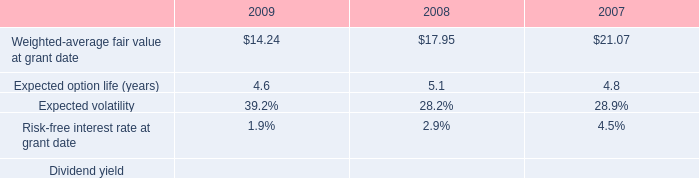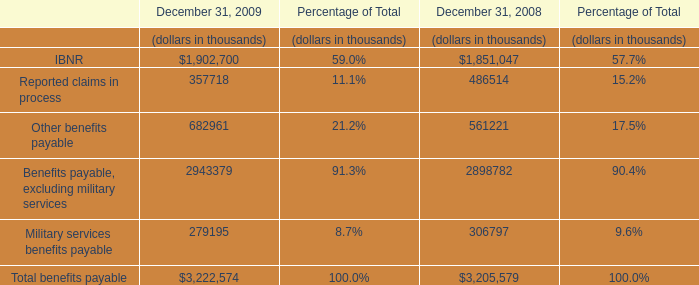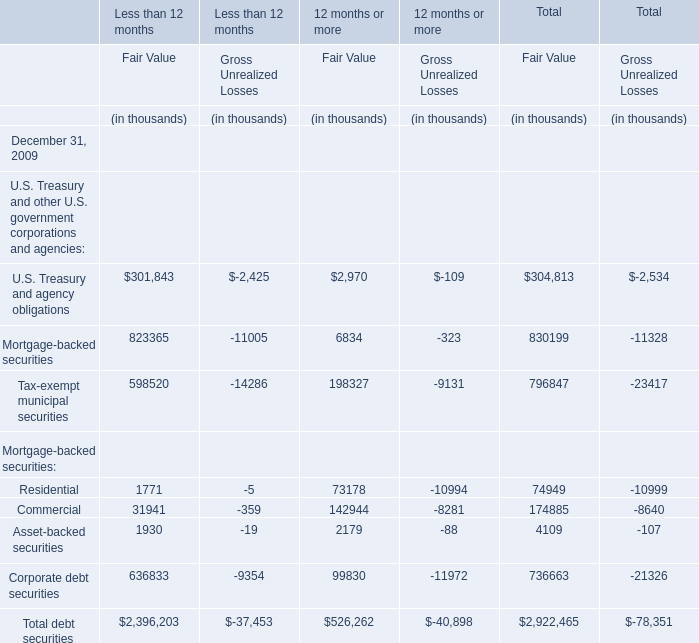what was the percent of the change of the expected volatility from 2008 to 2009 
Computations: ((39.2 - 28.2) / 28.2)
Answer: 0.39007. 